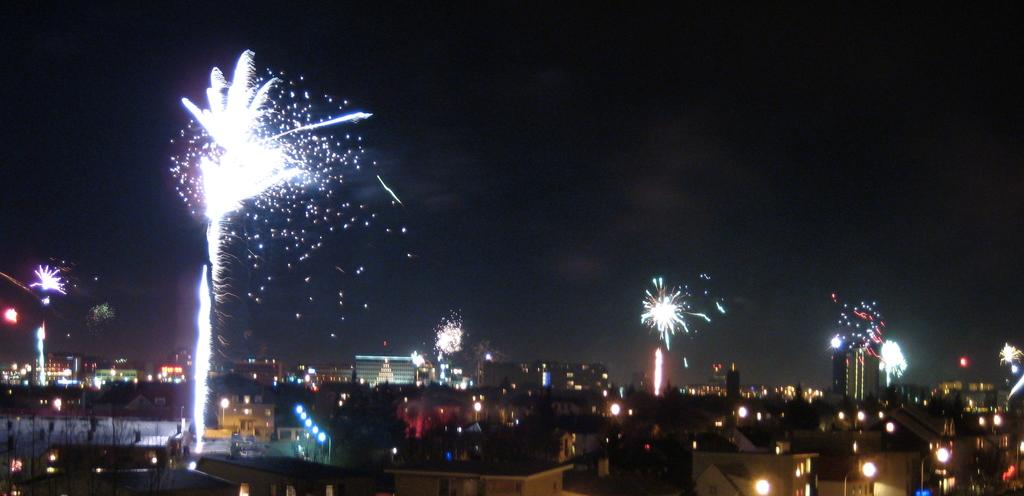What type of structures can be seen in the image? There are buildings in the image. What natural phenomenon is depicted in the image? There are lightnings in the image. What type of linen is being used to cover the graves in the image? There is no mention of graves or linen in the image; it features buildings and lightnings. 